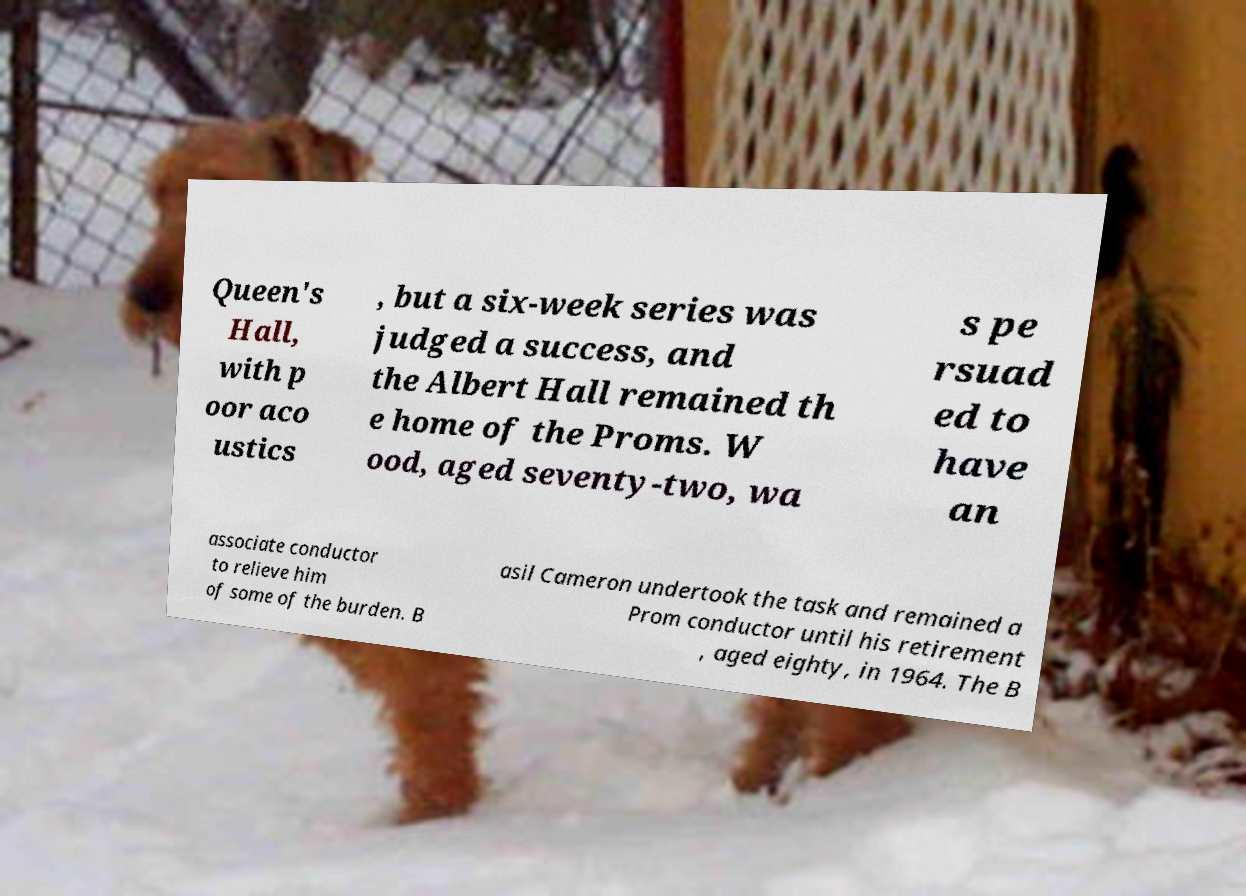Can you accurately transcribe the text from the provided image for me? Queen's Hall, with p oor aco ustics , but a six-week series was judged a success, and the Albert Hall remained th e home of the Proms. W ood, aged seventy-two, wa s pe rsuad ed to have an associate conductor to relieve him of some of the burden. B asil Cameron undertook the task and remained a Prom conductor until his retirement , aged eighty, in 1964. The B 